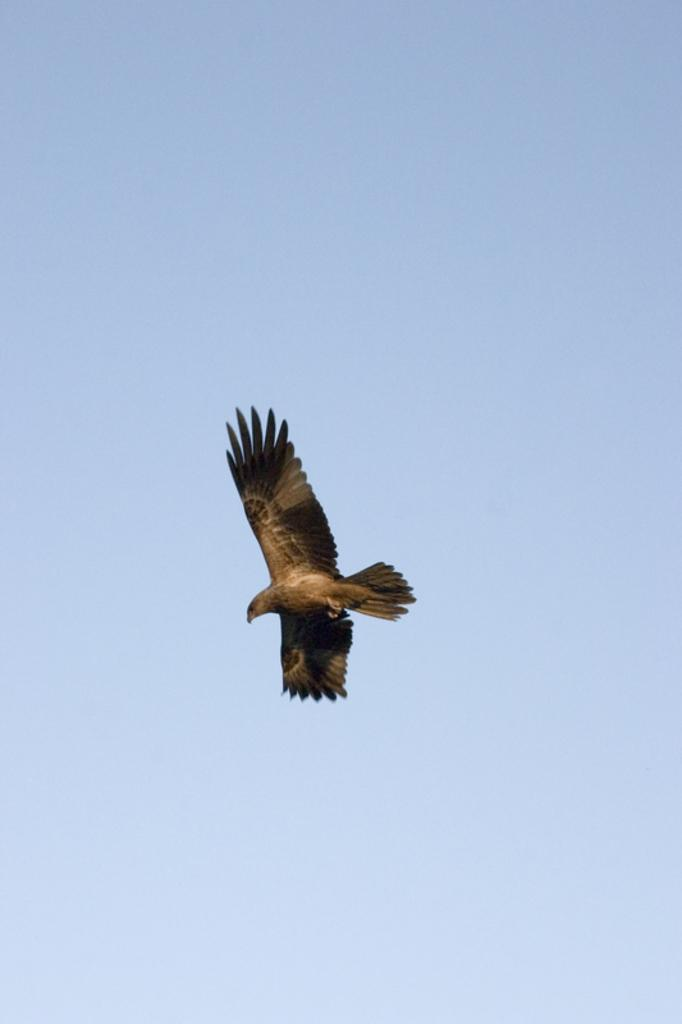What is the main subject of the image? There is a bird flying in the air in the image. What can be seen in the background of the image? The sky is visible in the background of the image. What is the color of the sky in the image? The sky is blue in the image. Are there any additional features in the sky? Yes, there are clouds in the sky. Can you see any nails being hammered into the bird in the image? No, there are no nails or any indication of hammering in the image. The image only shows a bird flying in the air with a blue sky and clouds in the background. 